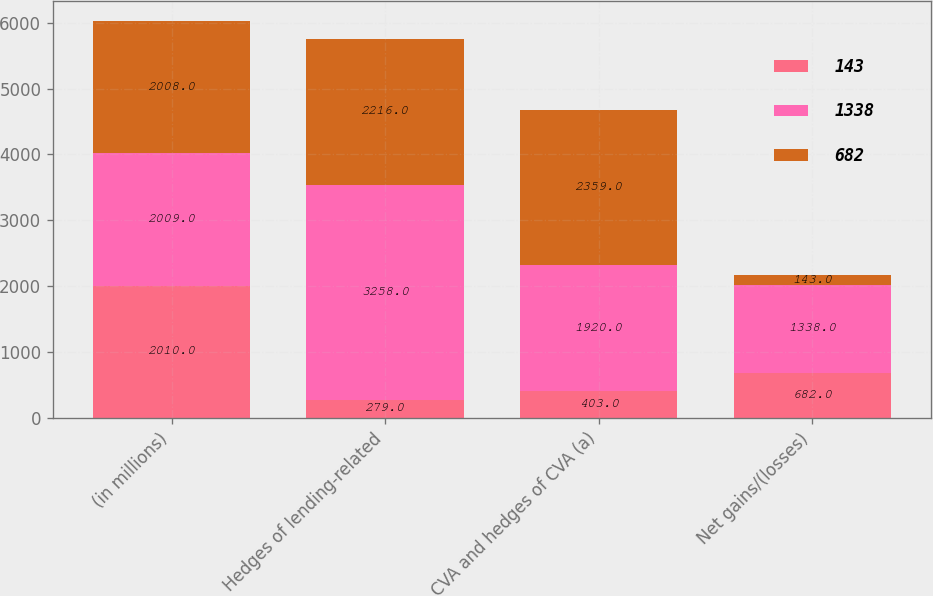<chart> <loc_0><loc_0><loc_500><loc_500><stacked_bar_chart><ecel><fcel>(in millions)<fcel>Hedges of lending-related<fcel>CVA and hedges of CVA (a)<fcel>Net gains/(losses)<nl><fcel>143<fcel>2010<fcel>279<fcel>403<fcel>682<nl><fcel>1338<fcel>2009<fcel>3258<fcel>1920<fcel>1338<nl><fcel>682<fcel>2008<fcel>2216<fcel>2359<fcel>143<nl></chart> 